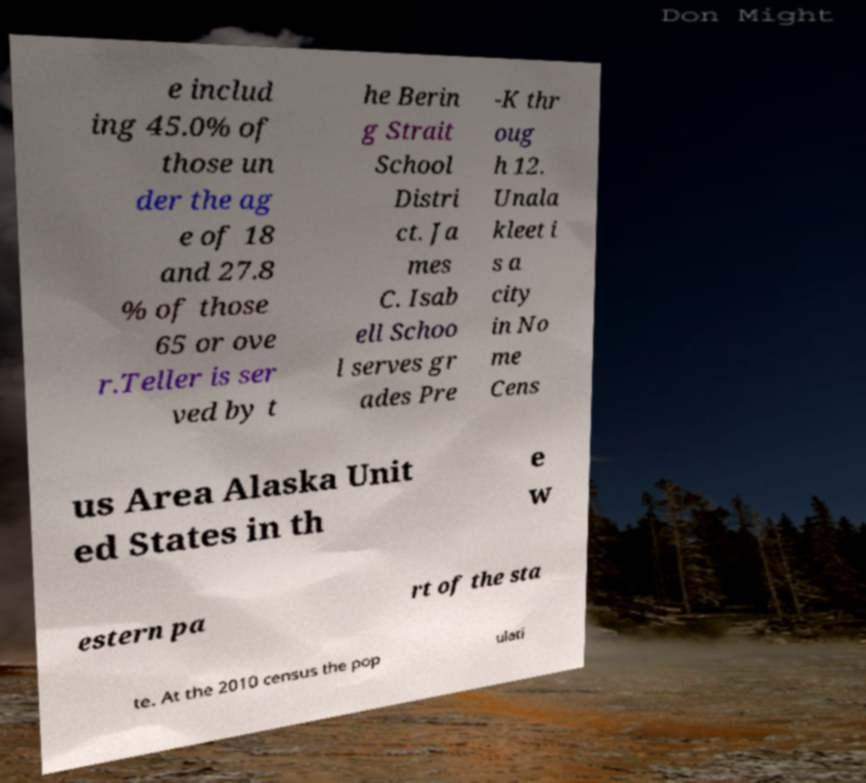Could you extract and type out the text from this image? e includ ing 45.0% of those un der the ag e of 18 and 27.8 % of those 65 or ove r.Teller is ser ved by t he Berin g Strait School Distri ct. Ja mes C. Isab ell Schoo l serves gr ades Pre -K thr oug h 12. Unala kleet i s a city in No me Cens us Area Alaska Unit ed States in th e w estern pa rt of the sta te. At the 2010 census the pop ulati 